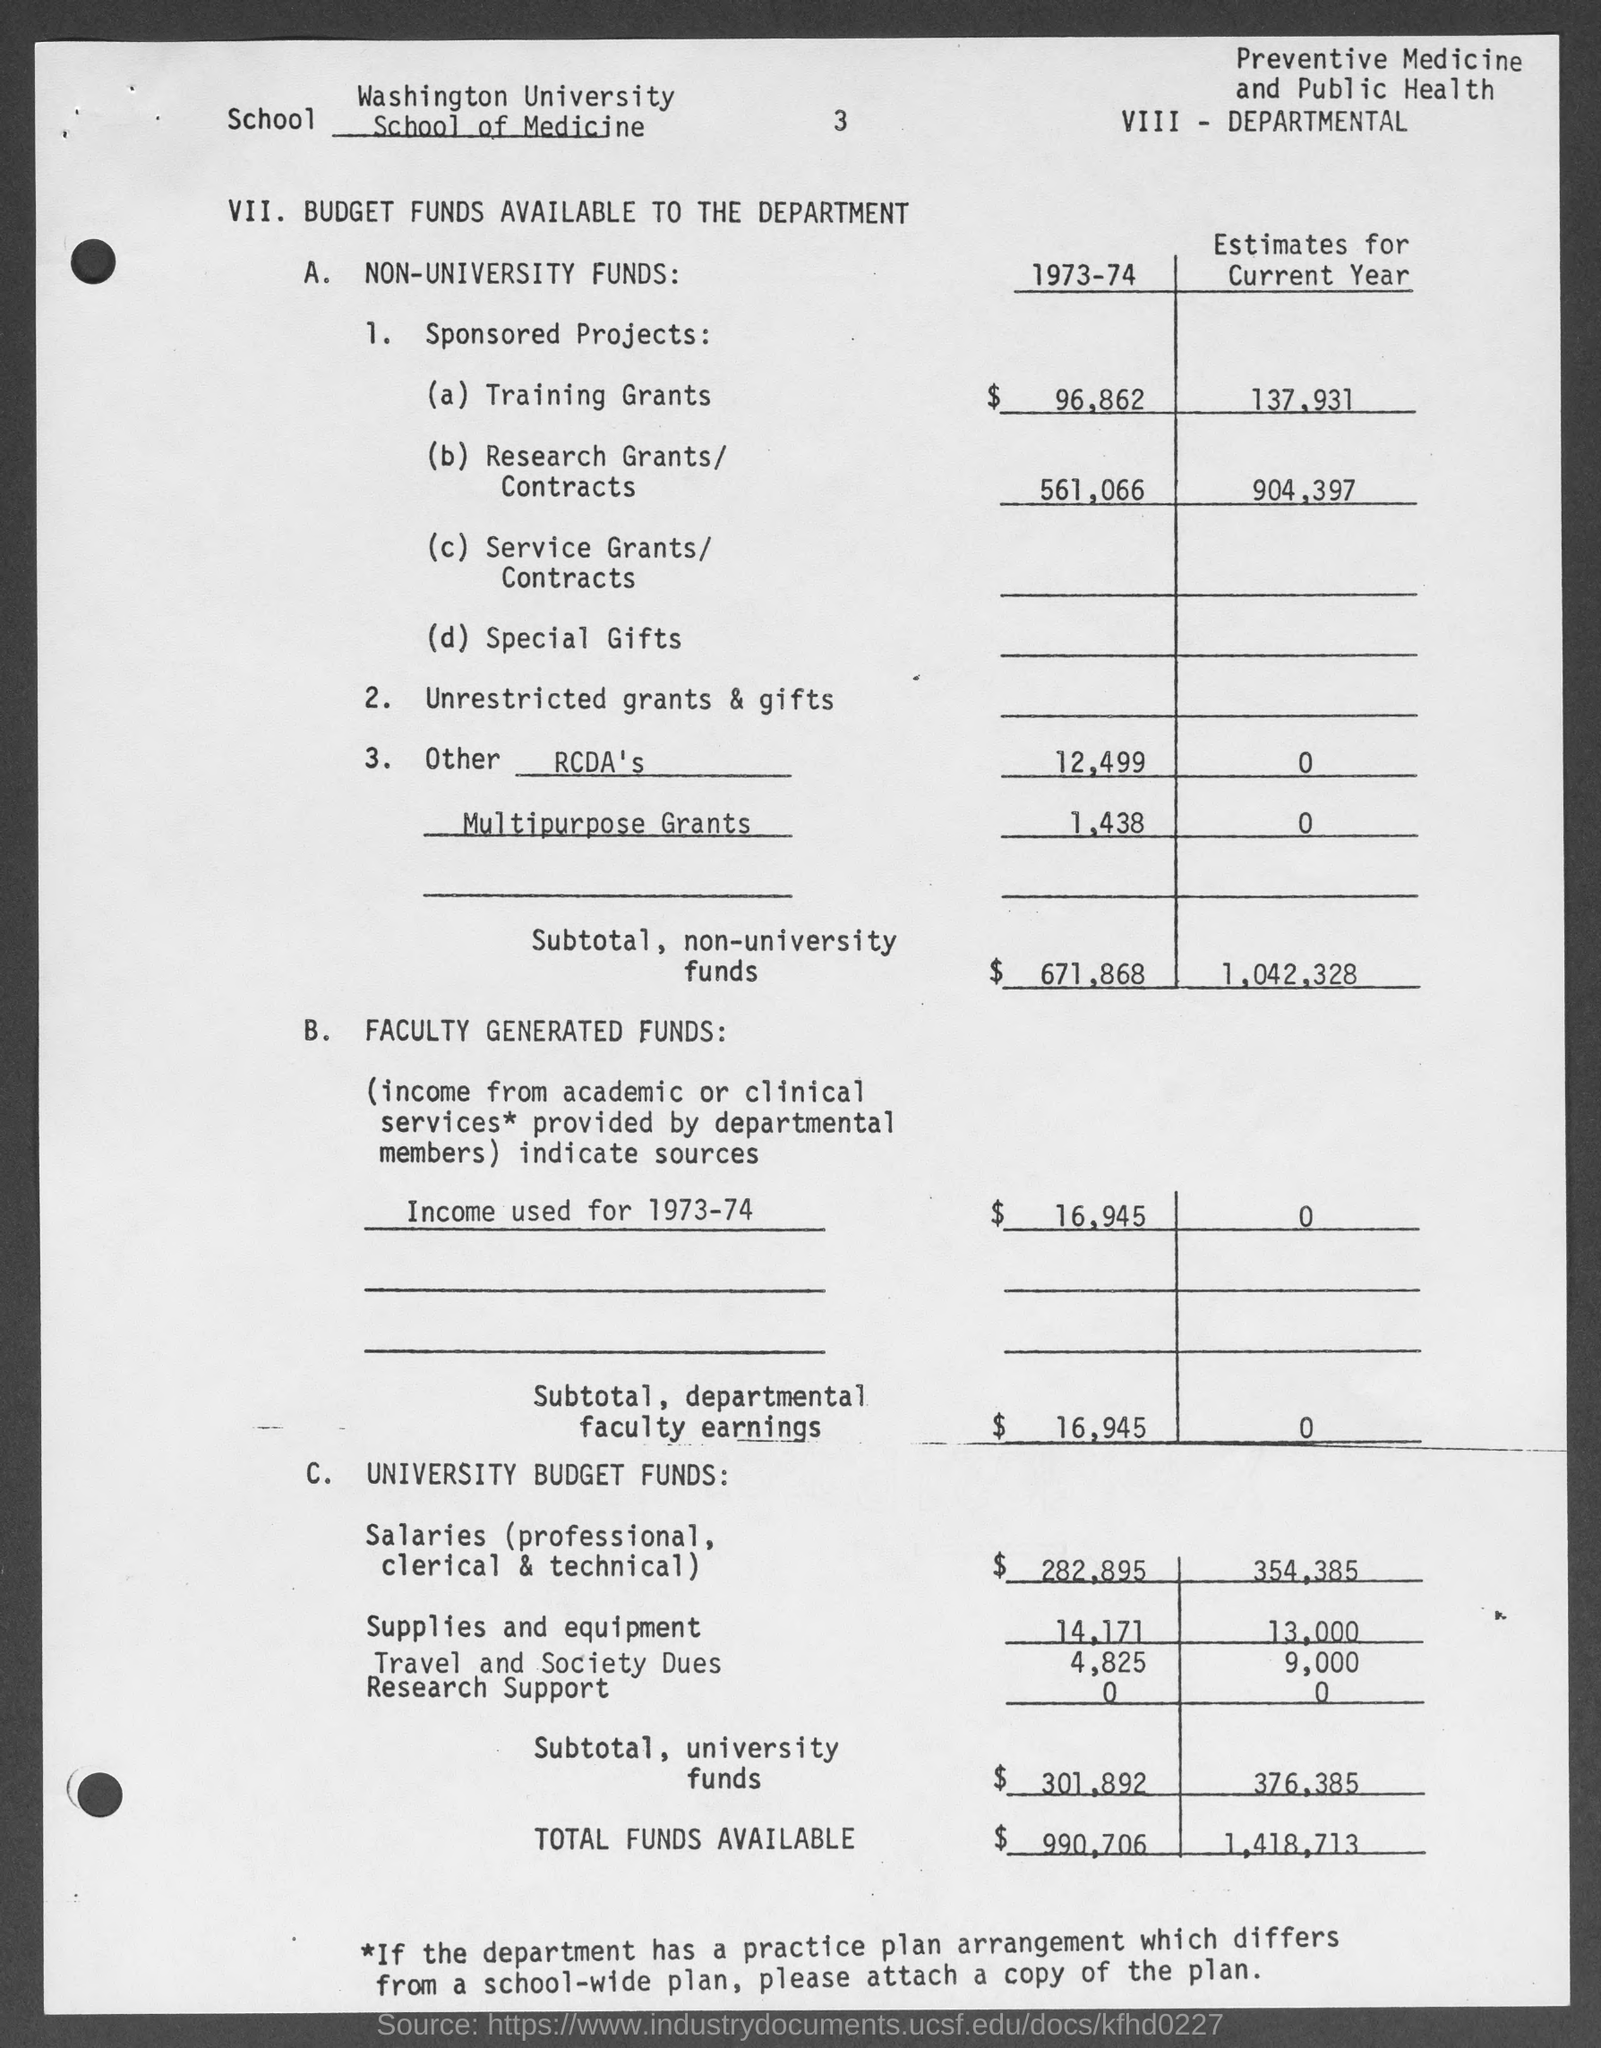Which university school's budget is given here?
Offer a very short reply. Washington University School of Medicine. What is the budget estimate of subtotal of departmental faculty earning during the year 1973-74?
Your response must be concise. 16,945. What is the budget estimate of total funds available during the year 1973-74?
Keep it short and to the point. $ 990,706. 